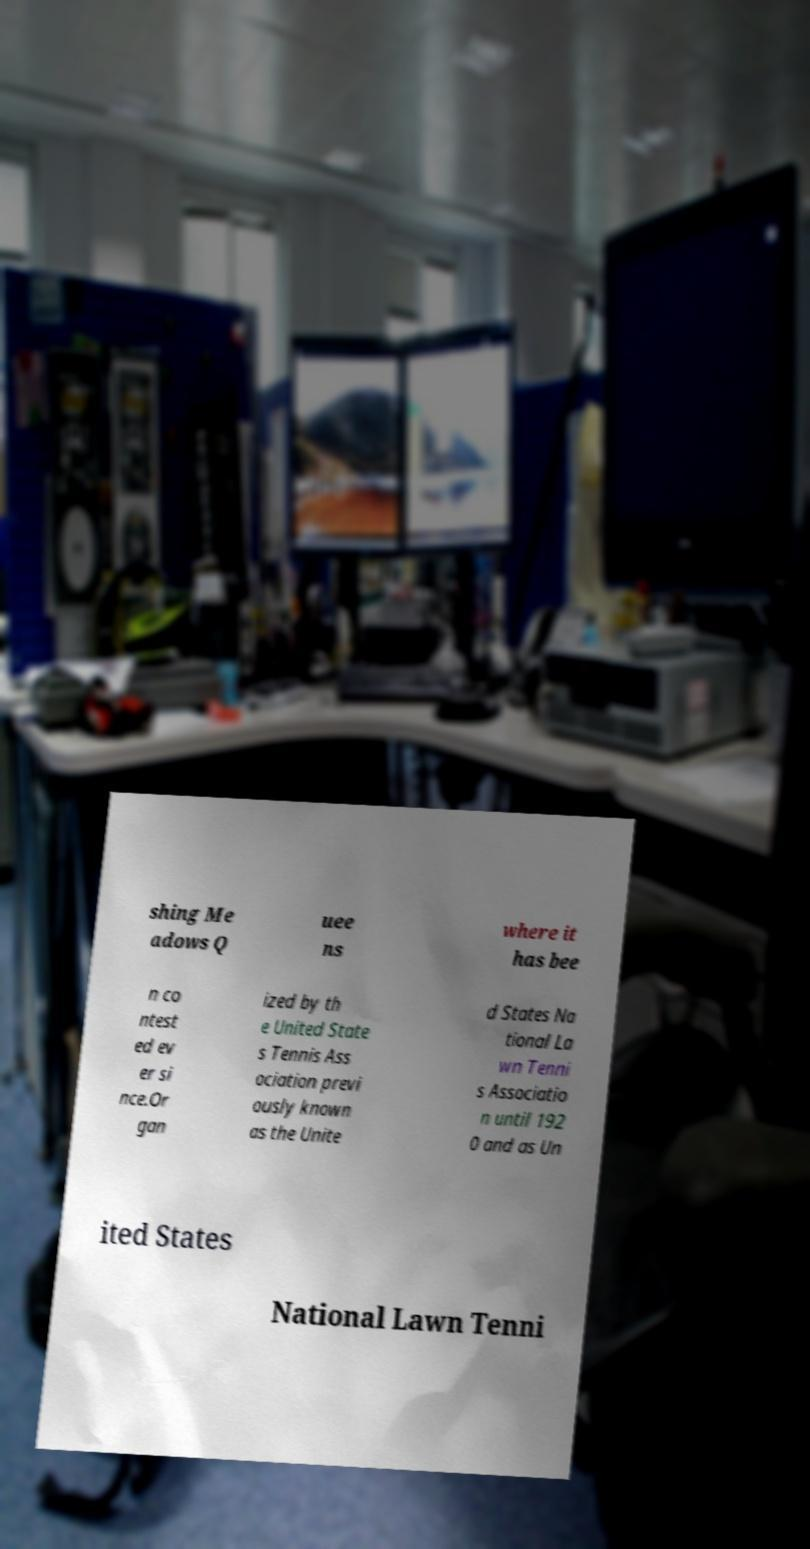There's text embedded in this image that I need extracted. Can you transcribe it verbatim? shing Me adows Q uee ns where it has bee n co ntest ed ev er si nce.Or gan ized by th e United State s Tennis Ass ociation previ ously known as the Unite d States Na tional La wn Tenni s Associatio n until 192 0 and as Un ited States National Lawn Tenni 